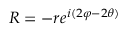<formula> <loc_0><loc_0><loc_500><loc_500>R = - r e ^ { i ( 2 \varphi - 2 \theta ) }</formula> 